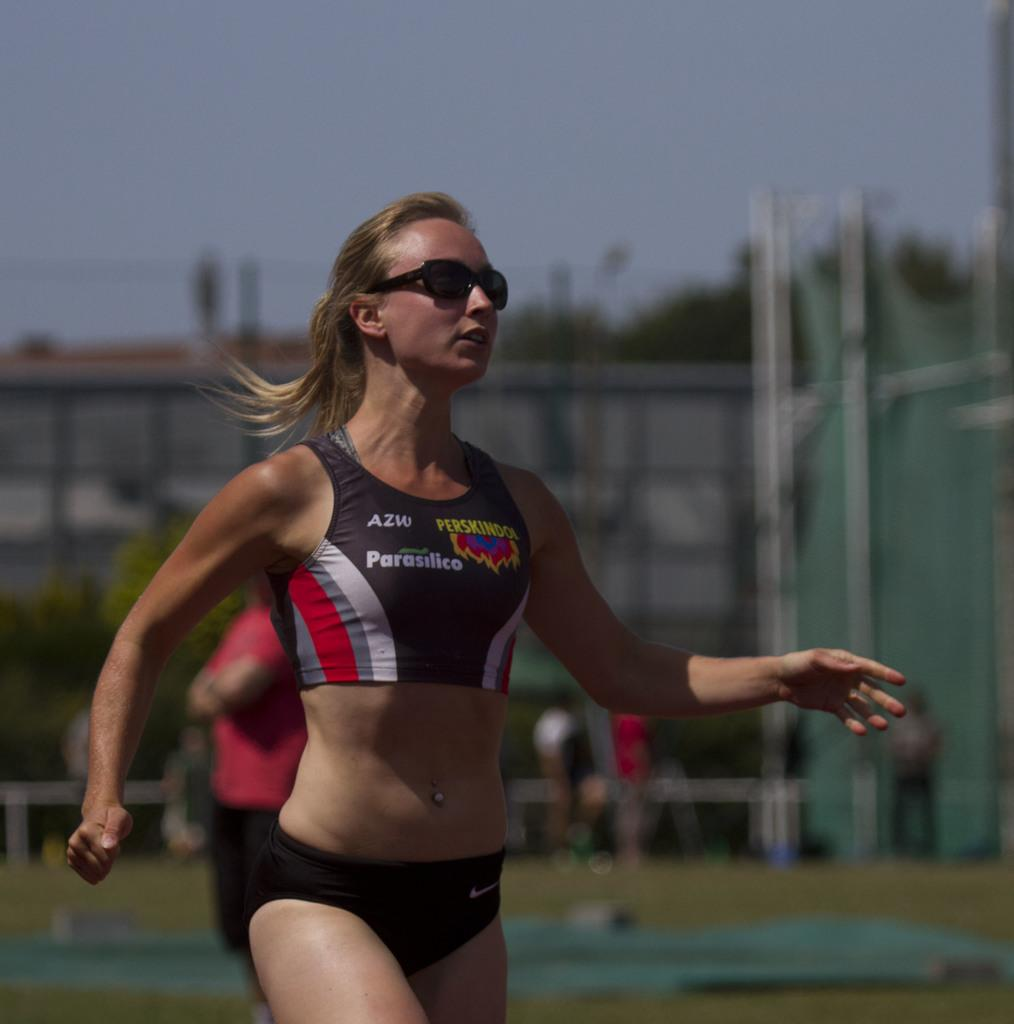<image>
Relay a brief, clear account of the picture shown. a woman runner in an AZW black and white outfit 